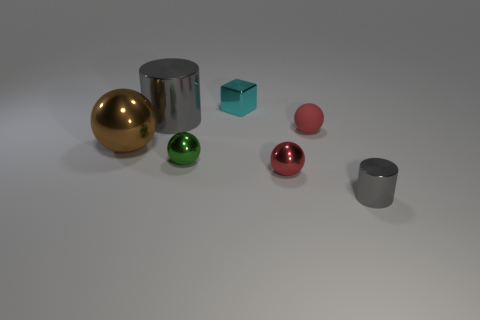Subtract 1 spheres. How many spheres are left? 3 Subtract all red blocks. Subtract all gray balls. How many blocks are left? 1 Add 1 large gray shiny cylinders. How many objects exist? 8 Subtract all cubes. How many objects are left? 6 Subtract all tiny red rubber balls. Subtract all small green balls. How many objects are left? 5 Add 3 red rubber balls. How many red rubber balls are left? 4 Add 5 blue matte cubes. How many blue matte cubes exist? 5 Subtract 0 green cylinders. How many objects are left? 7 